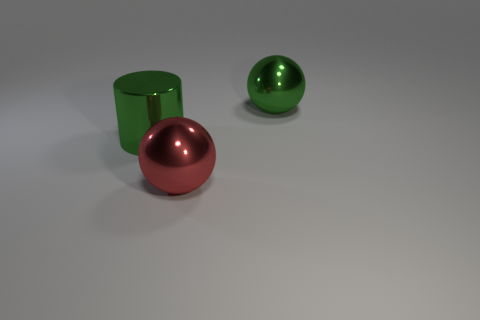There is a big green metal thing right of the red shiny ball; is its shape the same as the shiny thing that is in front of the big green cylinder? yes 